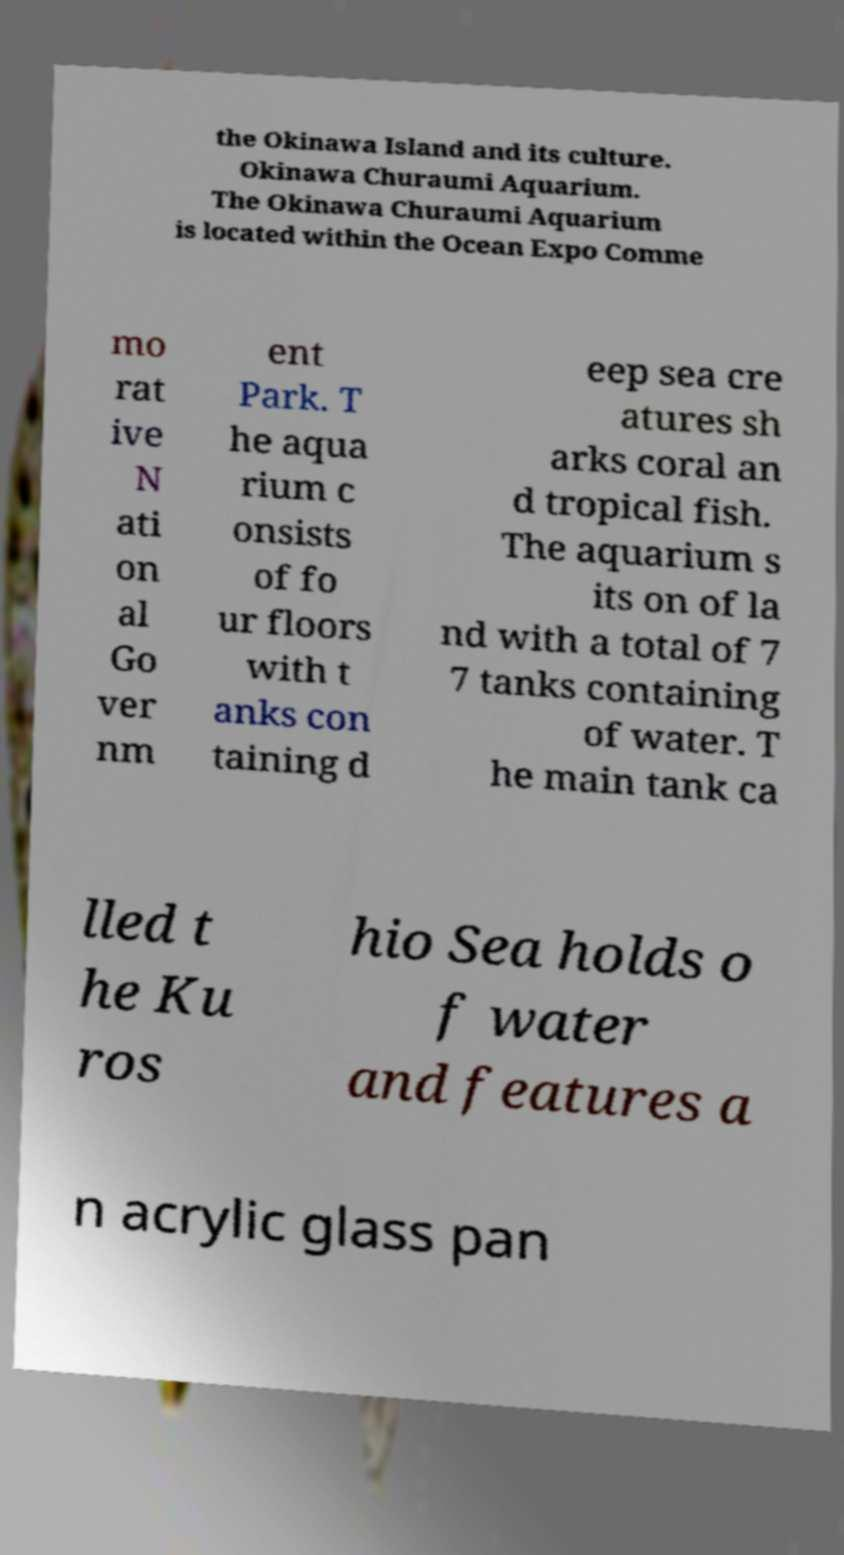Could you extract and type out the text from this image? the Okinawa Island and its culture. Okinawa Churaumi Aquarium. The Okinawa Churaumi Aquarium is located within the Ocean Expo Comme mo rat ive N ati on al Go ver nm ent Park. T he aqua rium c onsists of fo ur floors with t anks con taining d eep sea cre atures sh arks coral an d tropical fish. The aquarium s its on of la nd with a total of 7 7 tanks containing of water. T he main tank ca lled t he Ku ros hio Sea holds o f water and features a n acrylic glass pan 